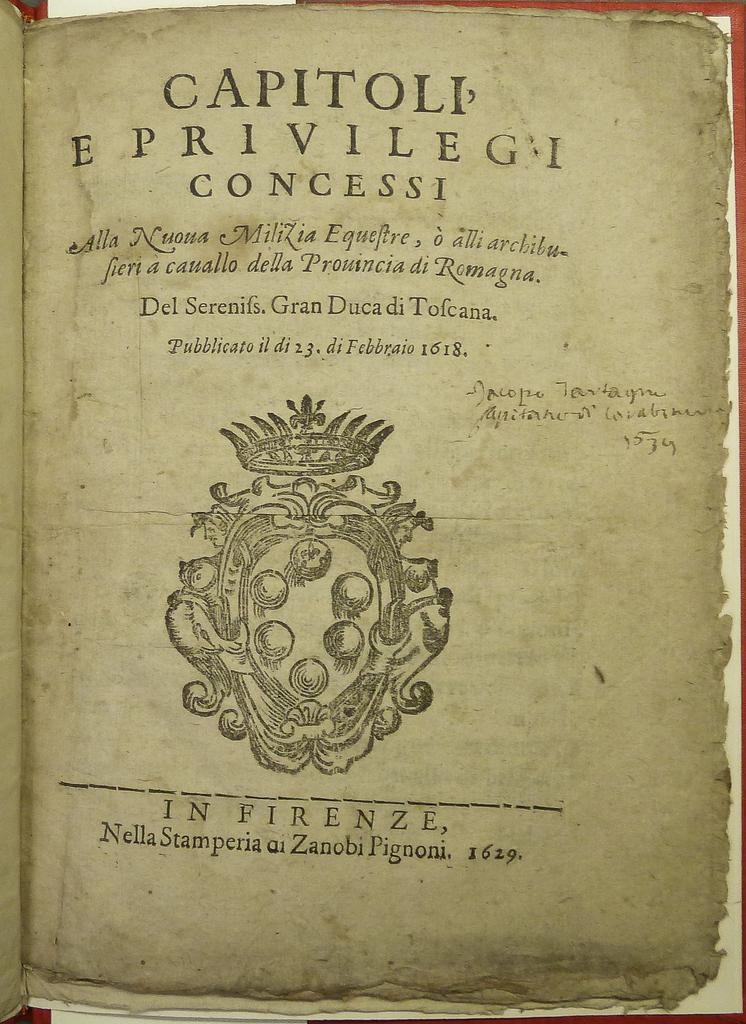<image>
Give a short and clear explanation of the subsequent image. The book was written in the year of 1629 